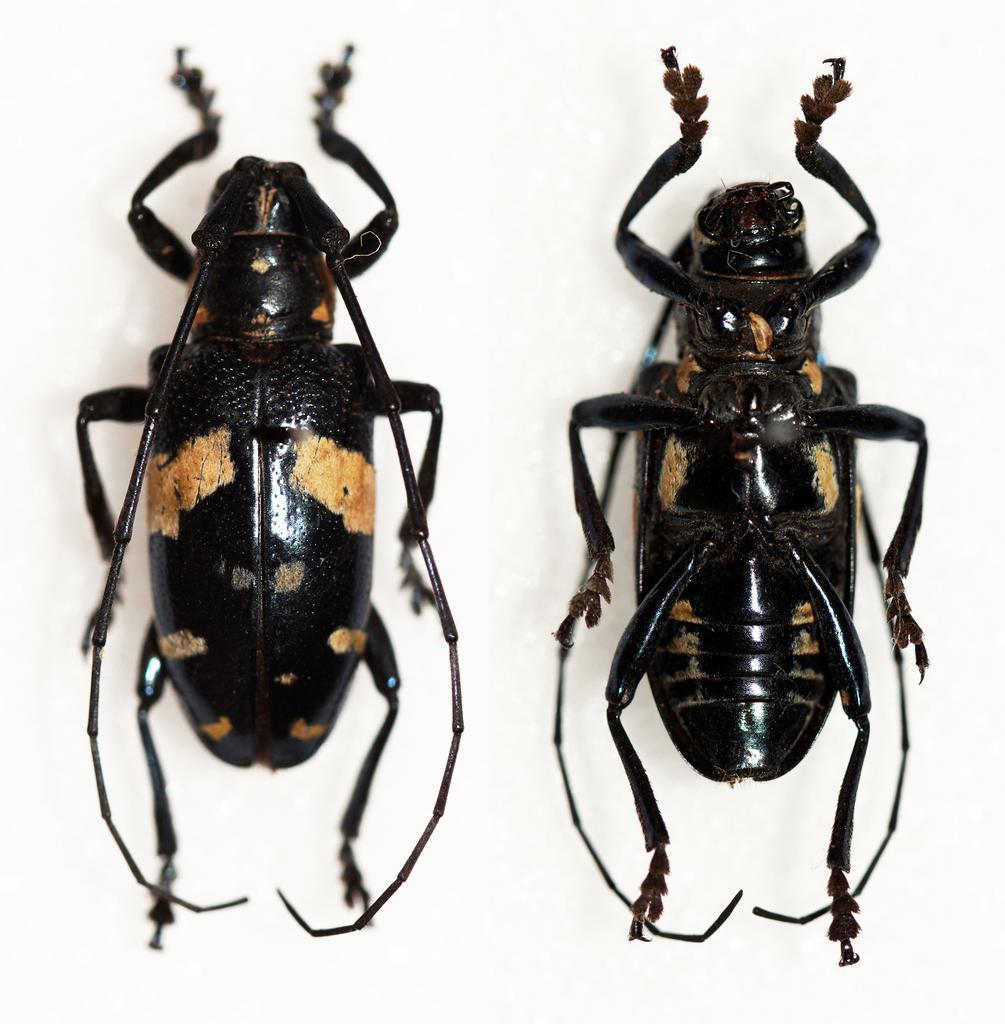Describe this image in one or two sentences. In this picture we can see insects on a white surface. 